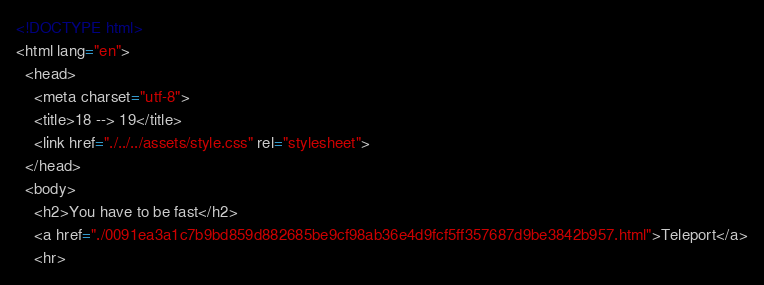Convert code to text. <code><loc_0><loc_0><loc_500><loc_500><_HTML_><!DOCTYPE html>
<html lang="en">
  <head>
    <meta charset="utf-8">
    <title>18 --> 19</title>
    <link href="./../../assets/style.css" rel="stylesheet">
  </head>
  <body>
    <h2>You have to be fast</h2>
    <a href="./0091ea3a1c7b9bd859d882685be9cf98ab36e4d9fcf5ff357687d9be3842b957.html">Teleport</a>
    <hr></code> 